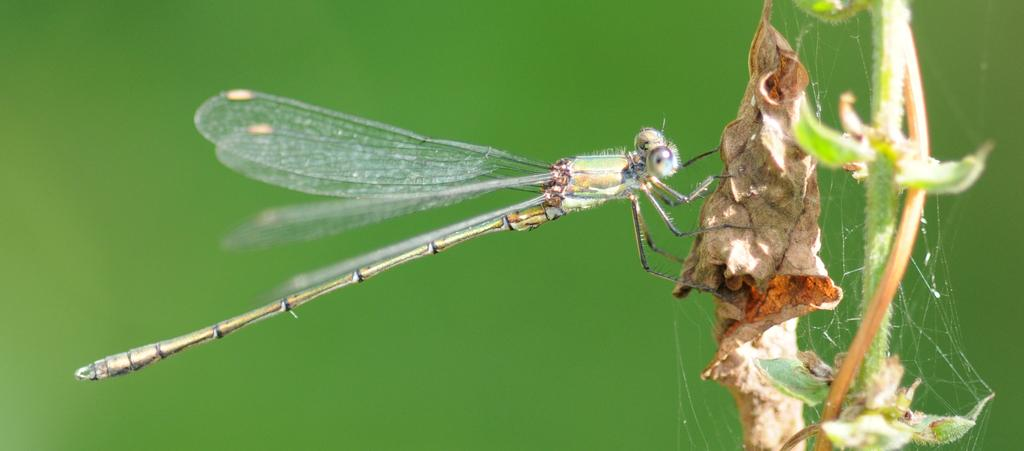What insect is present in the image? There is a dragonfly in the image. What is the dragonfly resting on? The dragonfly is on a dried leaf. What can be seen on the right side of the image? There is a spider web on the right side of the image. Where is the dragonfly's home located in the image? The image does not show the dragonfly's home, only the dragonfly itself and its location on a dried leaf. 